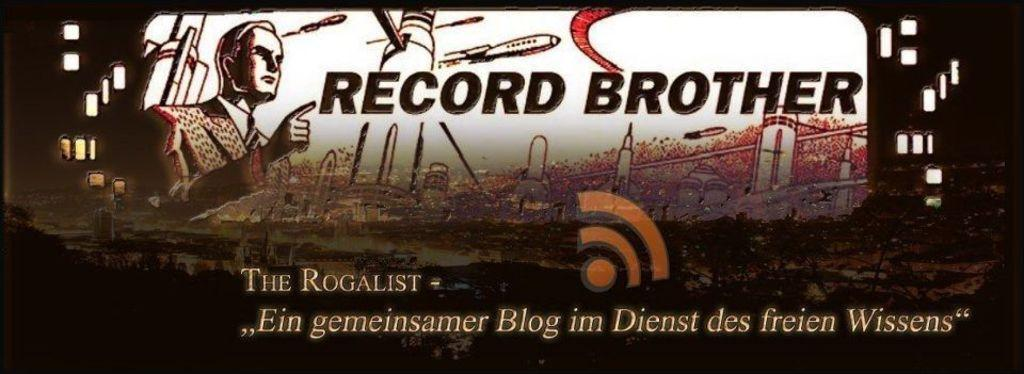What is the main object in the image? There is a poster in the image. What can be found on the poster? There are words, an image of a person, images of buildings, and other images on the poster. Can you describe the image of the person on the poster? Unfortunately, the specific details of the person's image cannot be determined from the provided facts. What type of pancake is being served in the image? There is no pancake present in the image; it features a poster with various elements. 